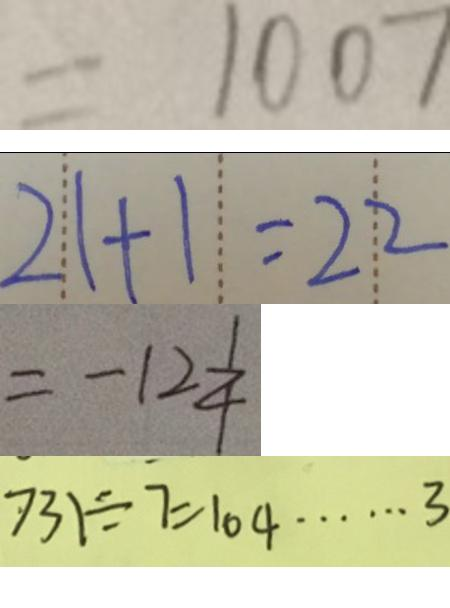Convert formula to latex. <formula><loc_0><loc_0><loc_500><loc_500>= 1 0 0 7 
 2 1 + 1 = 2 2 
 = - 1 2 \frac { 1 } { 4 } 
 7 3 1 \div 7 = 1 0 4 \cdots 3</formula> 